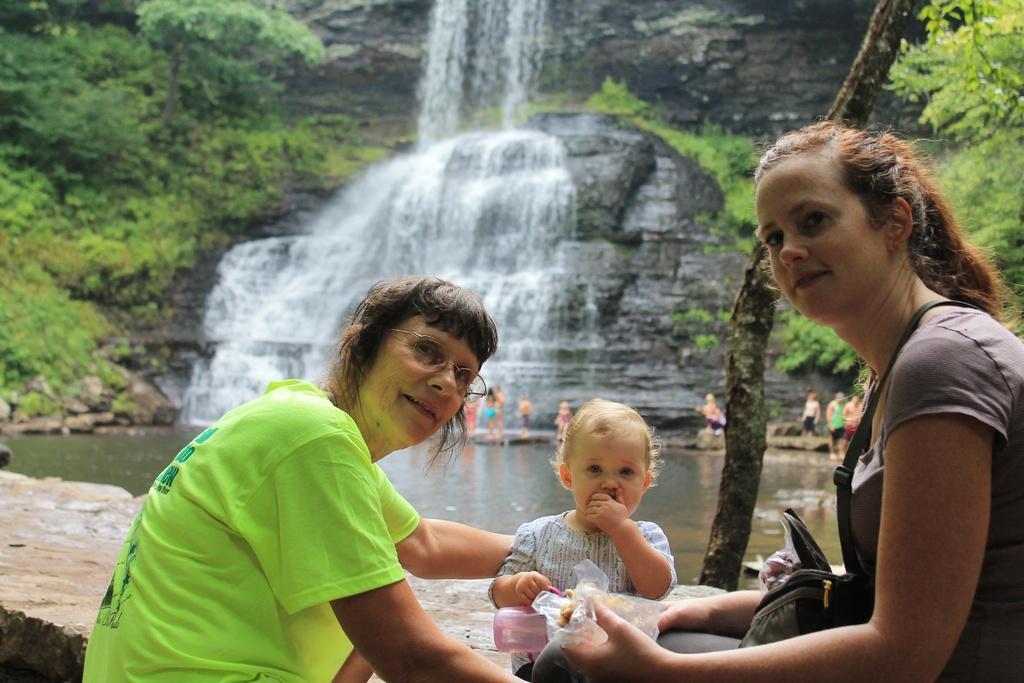Please provide a concise description of this image. In this image we can see two women and a child sitting on the surface. In that a woman is holding a bottle and a cover. On the backside we can see the bark of a tree, some trees, plants, a group of people standing beside a water body and the water flow on the hill. 